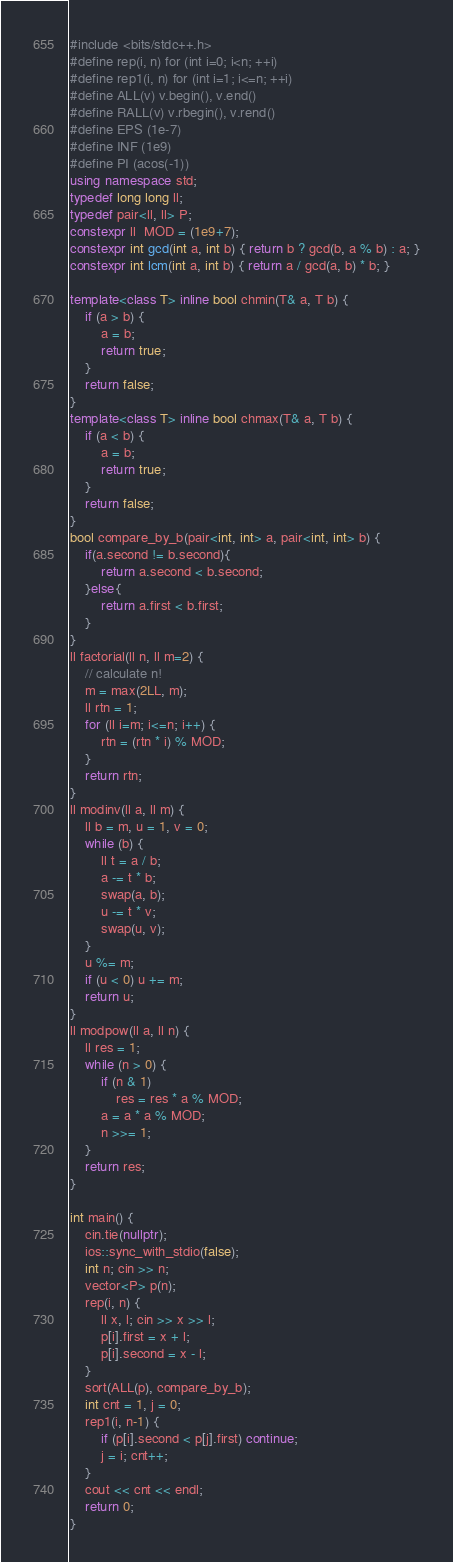Convert code to text. <code><loc_0><loc_0><loc_500><loc_500><_C++_>#include <bits/stdc++.h>
#define rep(i, n) for (int i=0; i<n; ++i)
#define rep1(i, n) for (int i=1; i<=n; ++i)
#define ALL(v) v.begin(), v.end()
#define RALL(v) v.rbegin(), v.rend()
#define EPS (1e-7)
#define INF (1e9)
#define PI (acos(-1))
using namespace std;
typedef long long ll;
typedef pair<ll, ll> P;
constexpr ll  MOD = (1e9+7);
constexpr int gcd(int a, int b) { return b ? gcd(b, a % b) : a; }
constexpr int lcm(int a, int b) { return a / gcd(a, b) * b; }

template<class T> inline bool chmin(T& a, T b) {
    if (a > b) {
        a = b;
        return true;
    }
    return false;
}
template<class T> inline bool chmax(T& a, T b) {
    if (a < b) {
        a = b;
        return true;
    }
    return false;
}
bool compare_by_b(pair<int, int> a, pair<int, int> b) {
    if(a.second != b.second){
        return a.second < b.second;
    }else{
        return a.first < b.first;
    }
}
ll factorial(ll n, ll m=2) {
    // calculate n!
    m = max(2LL, m);
    ll rtn = 1;
    for (ll i=m; i<=n; i++) {
        rtn = (rtn * i) % MOD;
    }
    return rtn;
}
ll modinv(ll a, ll m) {
    ll b = m, u = 1, v = 0;
    while (b) {
        ll t = a / b;
        a -= t * b;
        swap(a, b);
        u -= t * v;
        swap(u, v);
    }
    u %= m;
    if (u < 0) u += m;
    return u;
}
ll modpow(ll a, ll n) {
    ll res = 1;
    while (n > 0) {
        if (n & 1)
            res = res * a % MOD;
        a = a * a % MOD;
        n >>= 1;
    }
    return res;
}

int main() {
    cin.tie(nullptr);
    ios::sync_with_stdio(false);
    int n; cin >> n;
    vector<P> p(n);
    rep(i, n) {
        ll x, l; cin >> x >> l;
        p[i].first = x + l;
        p[i].second = x - l;
    }
    sort(ALL(p), compare_by_b);
    int cnt = 1, j = 0;
    rep1(i, n-1) {
        if (p[i].second < p[j].first) continue;
        j = i; cnt++;
    }
    cout << cnt << endl;
    return 0;
}</code> 